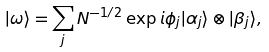Convert formula to latex. <formula><loc_0><loc_0><loc_500><loc_500>| \omega \rangle = \sum _ { j } N ^ { - 1 / 2 } \exp { i \phi _ { j } } | \alpha _ { j } \rangle \otimes | \beta _ { j } \rangle ,</formula> 